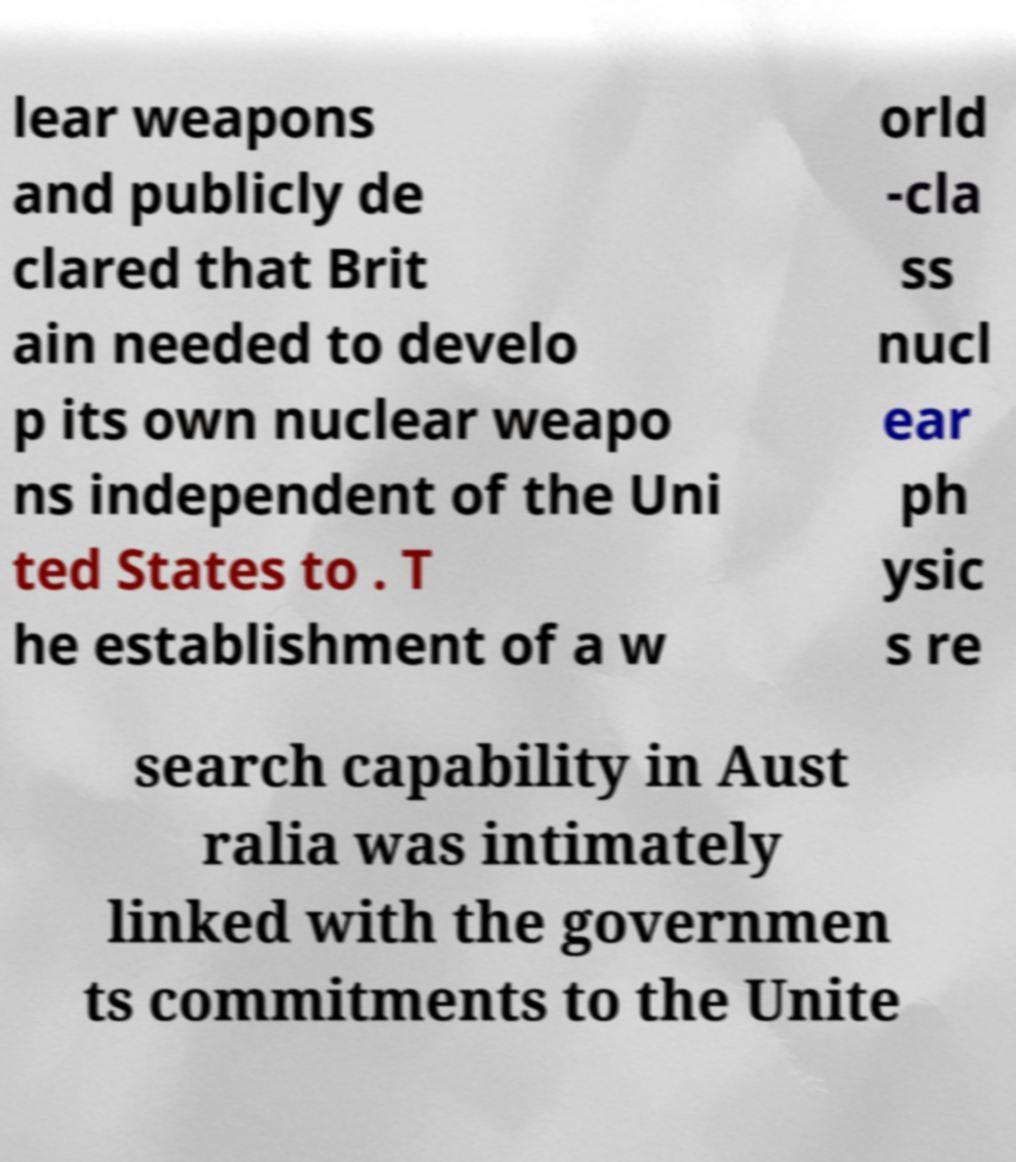Could you assist in decoding the text presented in this image and type it out clearly? lear weapons and publicly de clared that Brit ain needed to develo p its own nuclear weapo ns independent of the Uni ted States to . T he establishment of a w orld -cla ss nucl ear ph ysic s re search capability in Aust ralia was intimately linked with the governmen ts commitments to the Unite 